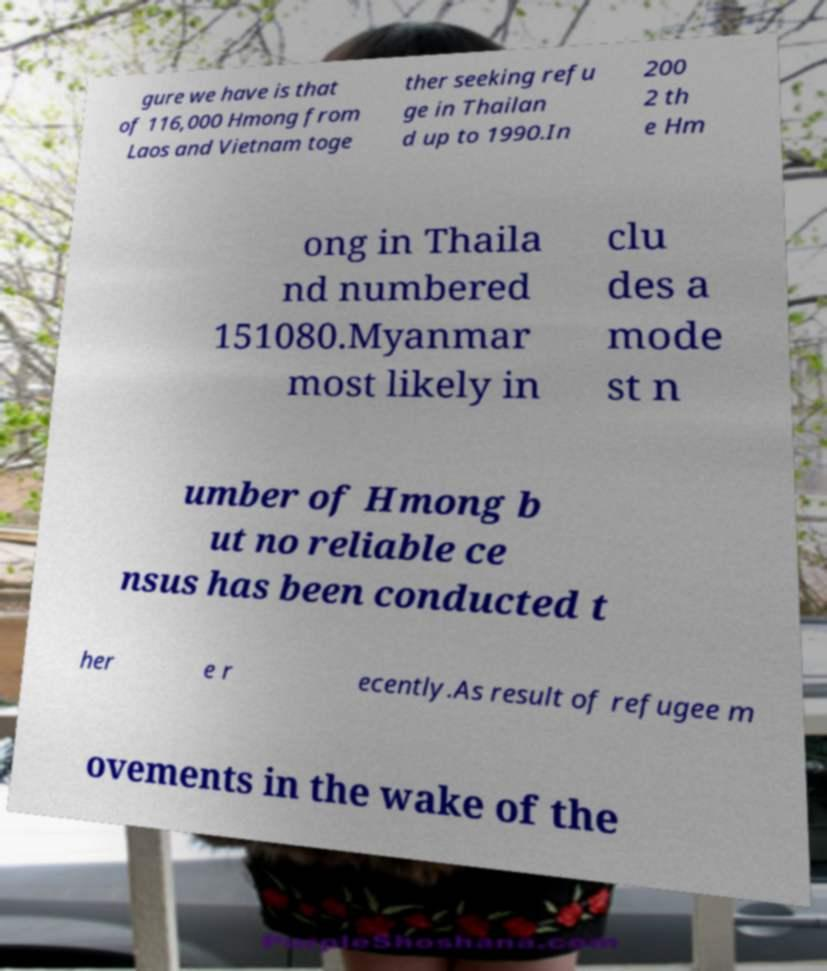I need the written content from this picture converted into text. Can you do that? gure we have is that of 116,000 Hmong from Laos and Vietnam toge ther seeking refu ge in Thailan d up to 1990.In 200 2 th e Hm ong in Thaila nd numbered 151080.Myanmar most likely in clu des a mode st n umber of Hmong b ut no reliable ce nsus has been conducted t her e r ecently.As result of refugee m ovements in the wake of the 